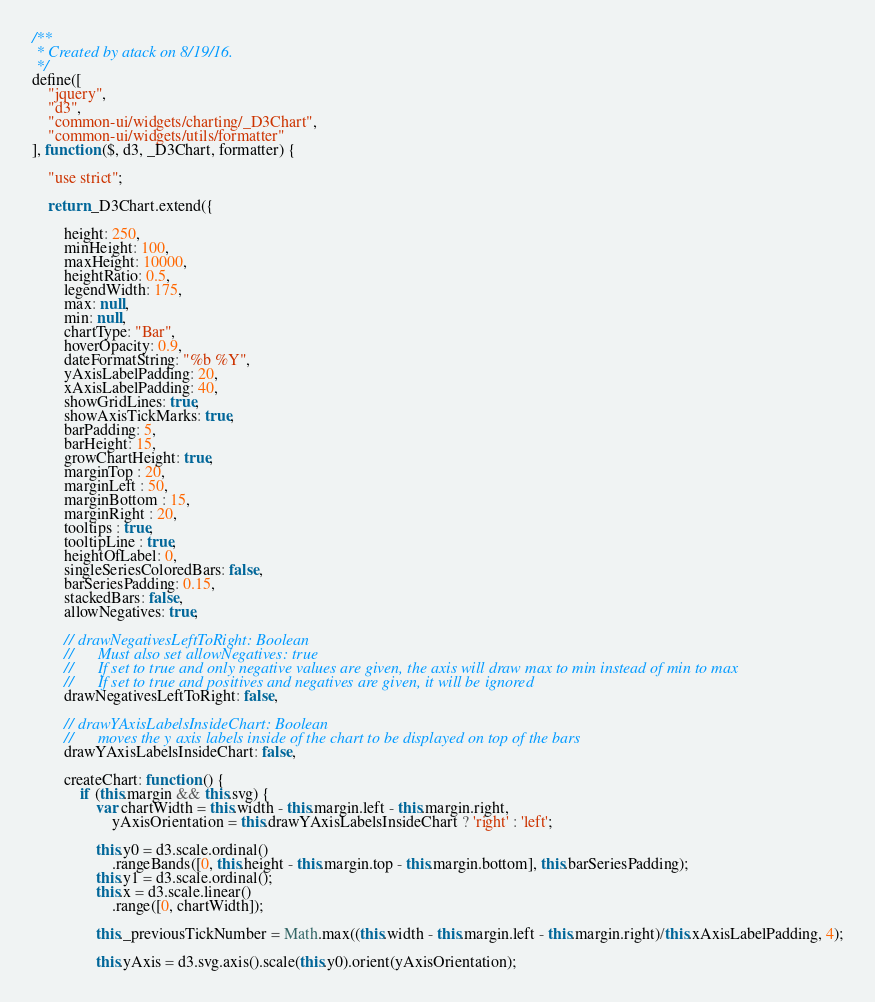<code> <loc_0><loc_0><loc_500><loc_500><_JavaScript_>/**
 * Created by atack on 8/19/16.
 */
define([
    "jquery",
    "d3",
    "common-ui/widgets/charting/_D3Chart",
    "common-ui/widgets/utils/formatter"
], function ($, d3, _D3Chart, formatter) {

    "use strict";

    return _D3Chart.extend({

        height: 250,
        minHeight: 100,
        maxHeight: 10000,
        heightRatio: 0.5,
        legendWidth: 175,
        max: null,
        min: null,
        chartType: "Bar",
        hoverOpacity: 0.9,
        dateFormatString: "%b %Y",
        yAxisLabelPadding: 20,
        xAxisLabelPadding: 40,
        showGridLines: true,
        showAxisTickMarks: true,
        barPadding: 5,
        barHeight: 15,
        growChartHeight: true,
        marginTop : 20,
        marginLeft : 50,
        marginBottom : 15,
        marginRight : 20,
        tooltips : true,
        tooltipLine : true,
        heightOfLabel: 0,
        singleSeriesColoredBars: false,
        barSeriesPadding: 0.15,
        stackedBars: false,
        allowNegatives: true,

        // drawNegativesLeftToRight: Boolean
        //      Must also set allowNegatives: true
        //      If set to true and only negative values are given, the axis will draw max to min instead of min to max
        //      If set to true and positives and negatives are given, it will be ignored
        drawNegativesLeftToRight: false,

        // drawYAxisLabelsInsideChart: Boolean
        //      moves the y axis labels inside of the chart to be displayed on top of the bars
        drawYAxisLabelsInsideChart: false,

        createChart: function () {
            if (this.margin && this.svg) {
                var chartWidth = this.width - this.margin.left - this.margin.right,
                    yAxisOrientation = this.drawYAxisLabelsInsideChart ? 'right' : 'left';

                this.y0 = d3.scale.ordinal()
                    .rangeBands([0, this.height - this.margin.top - this.margin.bottom], this.barSeriesPadding);
                this.y1 = d3.scale.ordinal();
                this.x = d3.scale.linear()
                    .range([0, chartWidth]);

                this._previousTickNumber = Math.max((this.width - this.margin.left - this.margin.right)/this.xAxisLabelPadding, 4);

                this.yAxis = d3.svg.axis().scale(this.y0).orient(yAxisOrientation);
</code> 